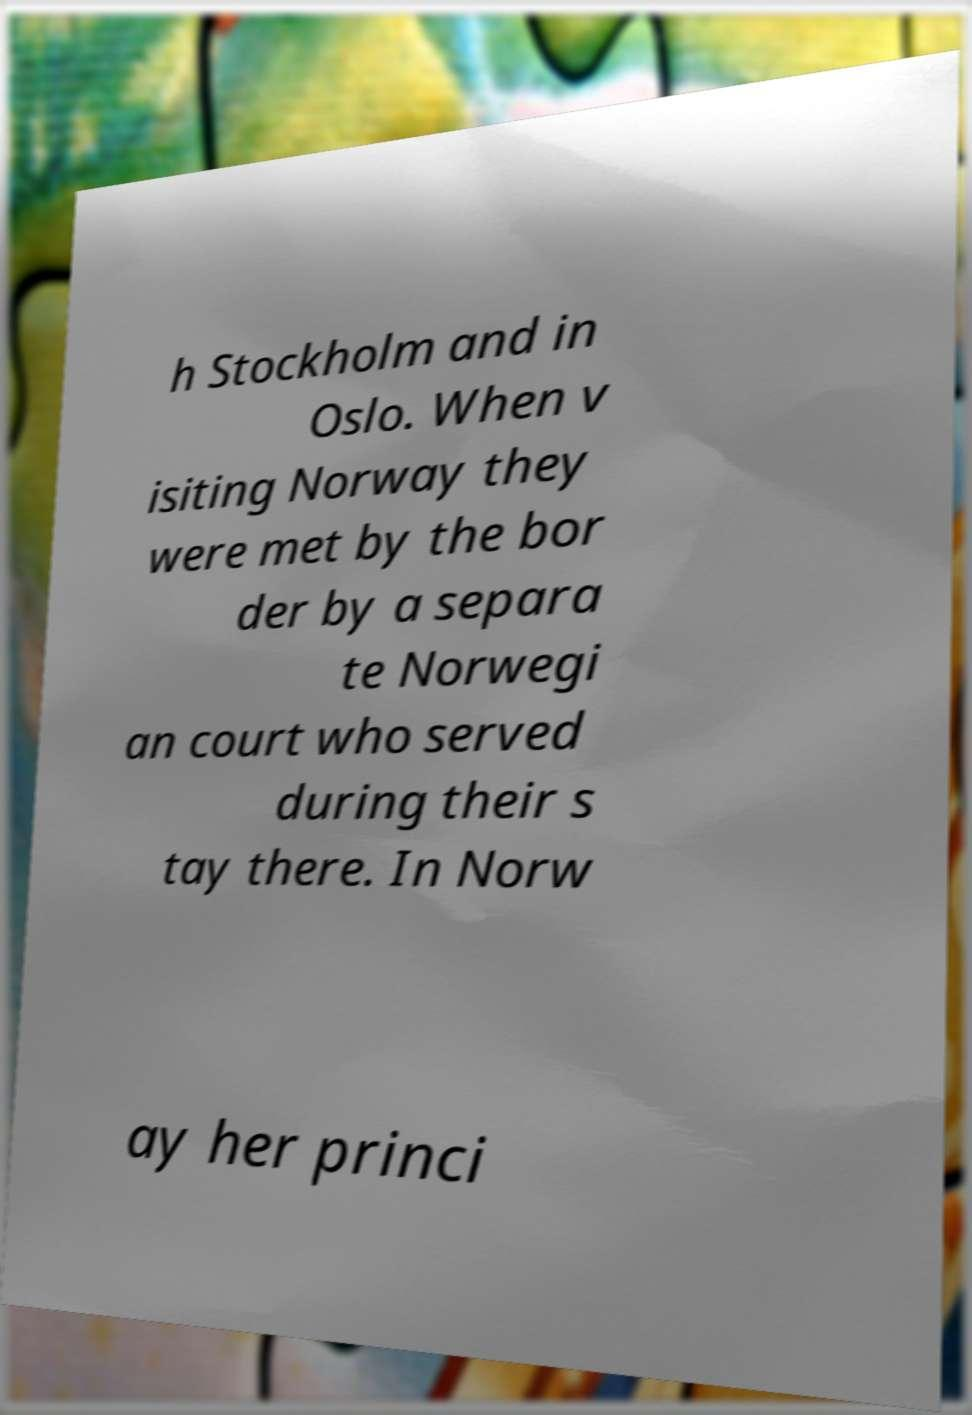There's text embedded in this image that I need extracted. Can you transcribe it verbatim? h Stockholm and in Oslo. When v isiting Norway they were met by the bor der by a separa te Norwegi an court who served during their s tay there. In Norw ay her princi 